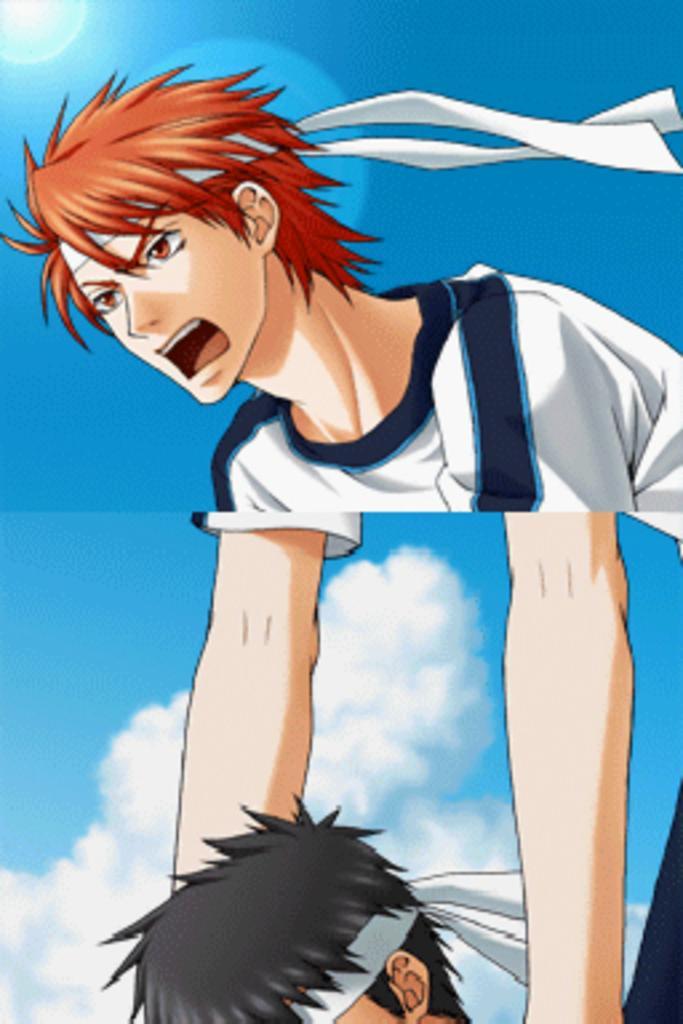Describe this image in one or two sentences. This is a collage of two images where we can see a cartoon picture of a person and the sky is in the background. 